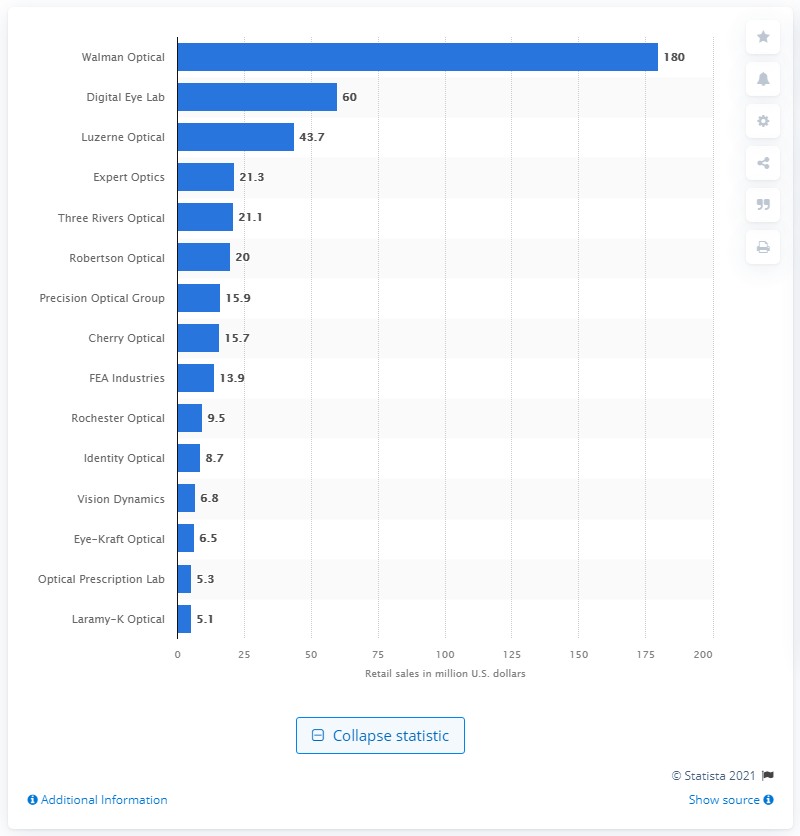Indicate a few pertinent items in this graphic. The prescription sales of Walman Optical in 2017 were approximately $180 million. Walman Optical was the leading independent vision lab in the United States in 2017. 